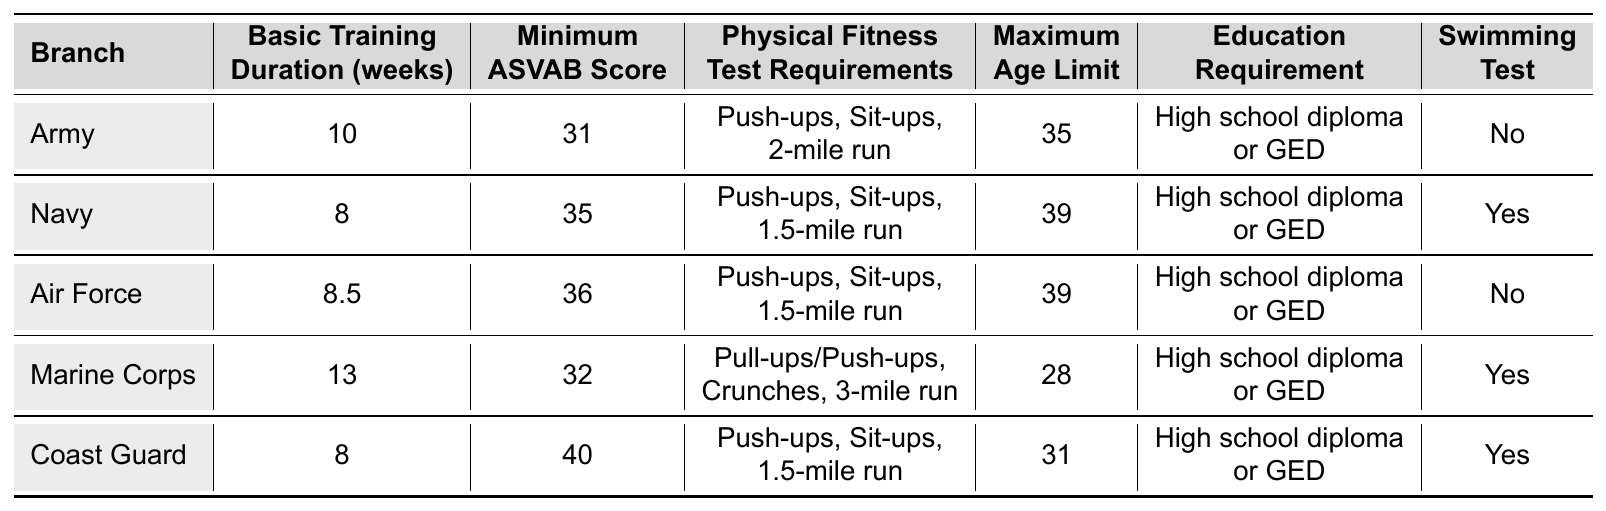What is the minimum ASVAB score required by the Coast Guard? In the table, the Coast Guard has a minimum ASVAB score of 40 listed.
Answer: 40 Which branch has the longest basic training duration? The Marine Corps has the longest basic training duration at 13 weeks, as per the data in the table.
Answer: Marine Corps What is the maximum age limit for joining the Marine Corps? The table states that the maximum age limit for the Marine Corps is 28 years.
Answer: 28 Which branches require a swimming test? The table shows that the Navy, Marine Corps, and Coast Guard require a swimming test.
Answer: Navy, Marine Corps, Coast Guard Calculate the average basic training duration across all branches. The durations are 10, 8, 8.5, 13, and 8 weeks. Adding these gives 47.5 weeks; dividing by the number of branches (5) gives an average of 9.5 weeks.
Answer: 9.5 Is the physical fitness test for the Army different from that of the Navy? Yes, the Army's test includes Push-ups, Sit-ups, and a 2-mile run, while the Navy's includes Push-ups, Sit-ups, and a 1.5-mile run, based on the table.
Answer: Yes Which branch has the highest minimum ASVAB score and what is that score? The Coast Guard has the highest minimum ASVAB score of 40. This is determined by comparing the ASVAB scores listed for all branches in the table.
Answer: Coast Guard, 40 How many branches have a basic training duration of less than 9 weeks? The Navy and Air Force both have a training duration of less than 9 weeks (8 and 8.5 weeks respectively). Therefore, there are 2 branches.
Answer: 2 Does the Army require a high school diploma or a GED? Yes, the table confirms that the Army requires either a high school diploma or GED for enrollment.
Answer: Yes What is the difference in basic training duration between the Army and the Marine Corps? The Army has a training duration of 10 weeks while the Marine Corps has 13 weeks. Subtracting these values gives a difference of 3 weeks.
Answer: 3 Are there any branches that do not require a swimming test? Yes, the Army and Air Force do not require a swimming test as noted in the table.
Answer: Yes 